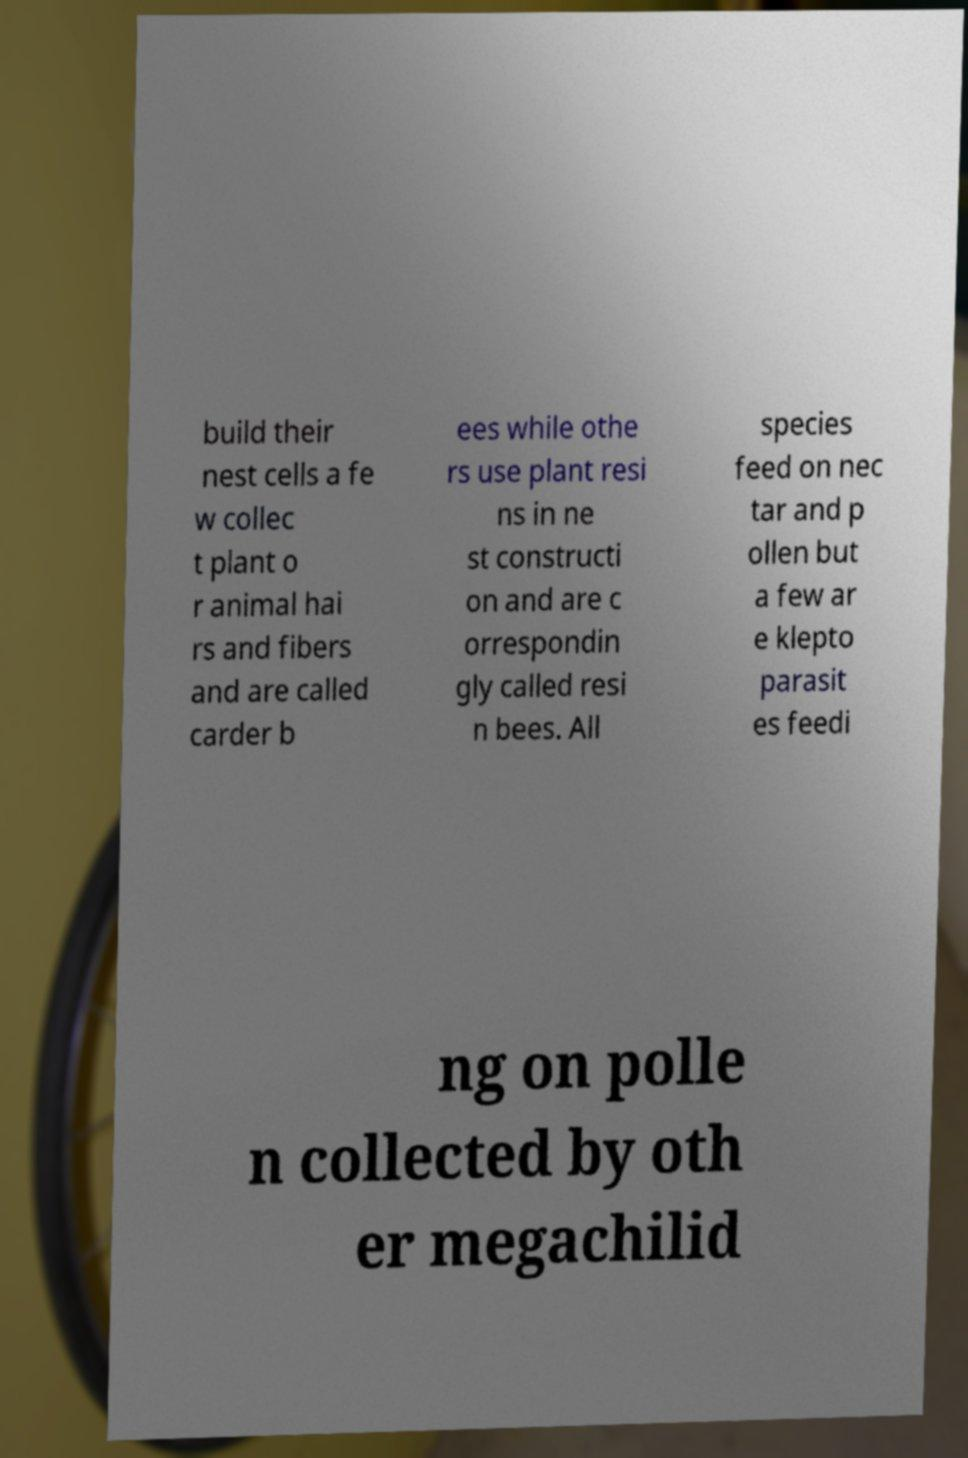There's text embedded in this image that I need extracted. Can you transcribe it verbatim? build their nest cells a fe w collec t plant o r animal hai rs and fibers and are called carder b ees while othe rs use plant resi ns in ne st constructi on and are c orrespondin gly called resi n bees. All species feed on nec tar and p ollen but a few ar e klepto parasit es feedi ng on polle n collected by oth er megachilid 